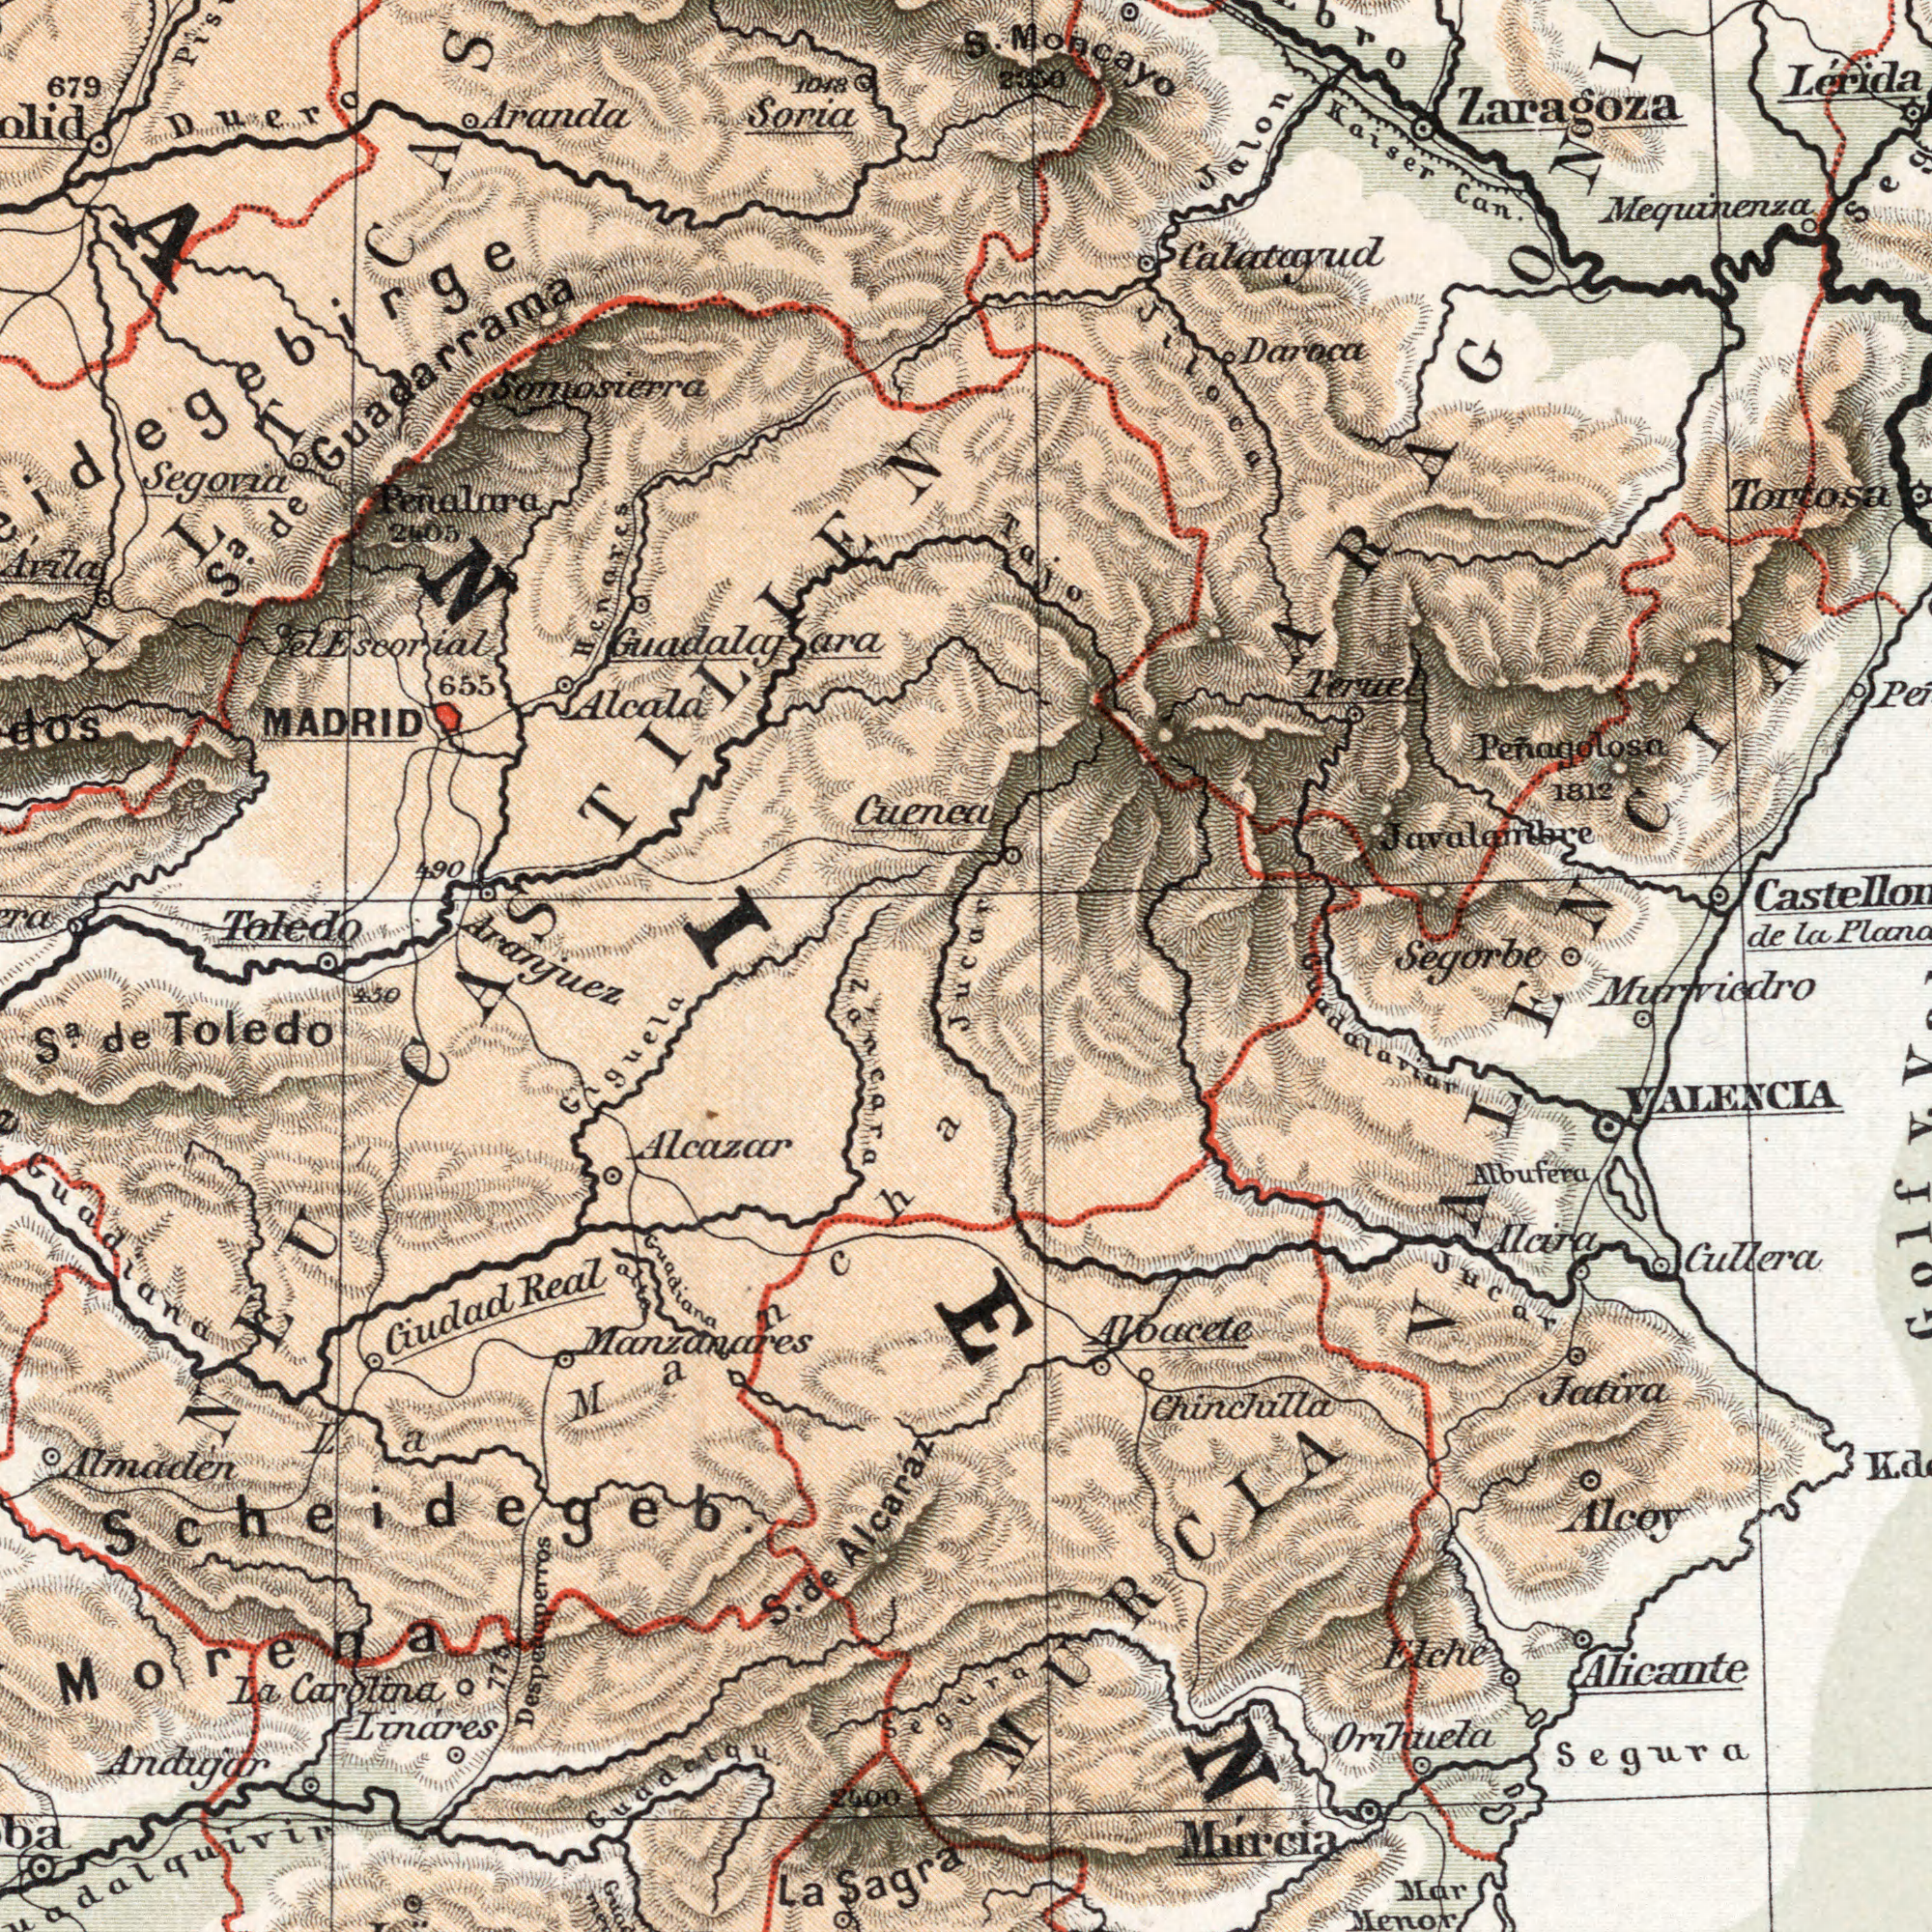What text is visible in the lower-left corner? Guadiana Guadiana alto LinÃ¡res S. de Alcaráz Andujar Sa. de Toledo Ciudad Real La Carolina Aleazar La Sagra Guadalgu 450 Giguela 2400 Manzanares Zancara Scheidegeb Almaden Segura Morena Despemaperros NEU 775 La Mancha What text is visible in the upper-right corner? Calatayud Zaragoza Peñagolosa Jiloca Kaiser Can. Terue Tortosa LÃ©rida Daroca Javalamirge 1812 lac S. Moncayo 2300 Mequinenza Segorbe Tajo Jalon What text is visible in the upper-left corner? Somosierra MADRID 679 Soria Aranda Penalara Toledo 655 Alcala Cuenca Segoria 1048 Duero 2405 490 Sa de Guadarrama el Escrial Henares CASTILLIEN ALT jucar Aranjuez What text can you see in the bottom-right section? Murcia Orihuela Alicante Cullera Elche Aloacete Alcira Mar Menor Alcoy VALENCIA Albufera Chinchilla Murviedro Jucar Segura MURCIA Guadalaviur Jativa VALENCIA 